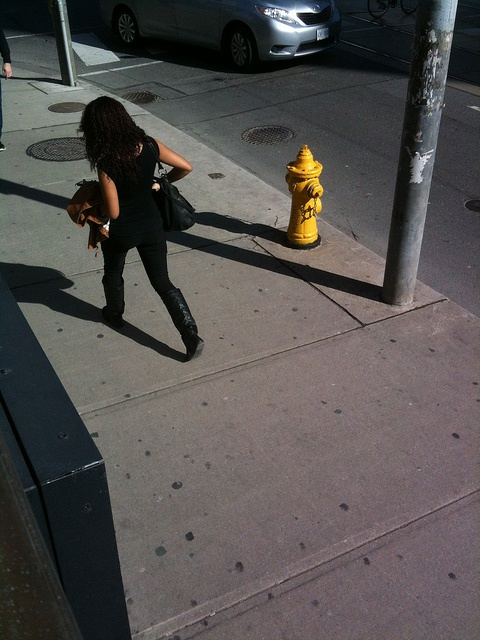Describe the objects in this image and their specific colors. I can see people in black, gray, and salmon tones, car in black, white, gray, and darkgray tones, fire hydrant in black, orange, maroon, and gold tones, handbag in black and gray tones, and people in black, gray, lightpink, and darkgray tones in this image. 